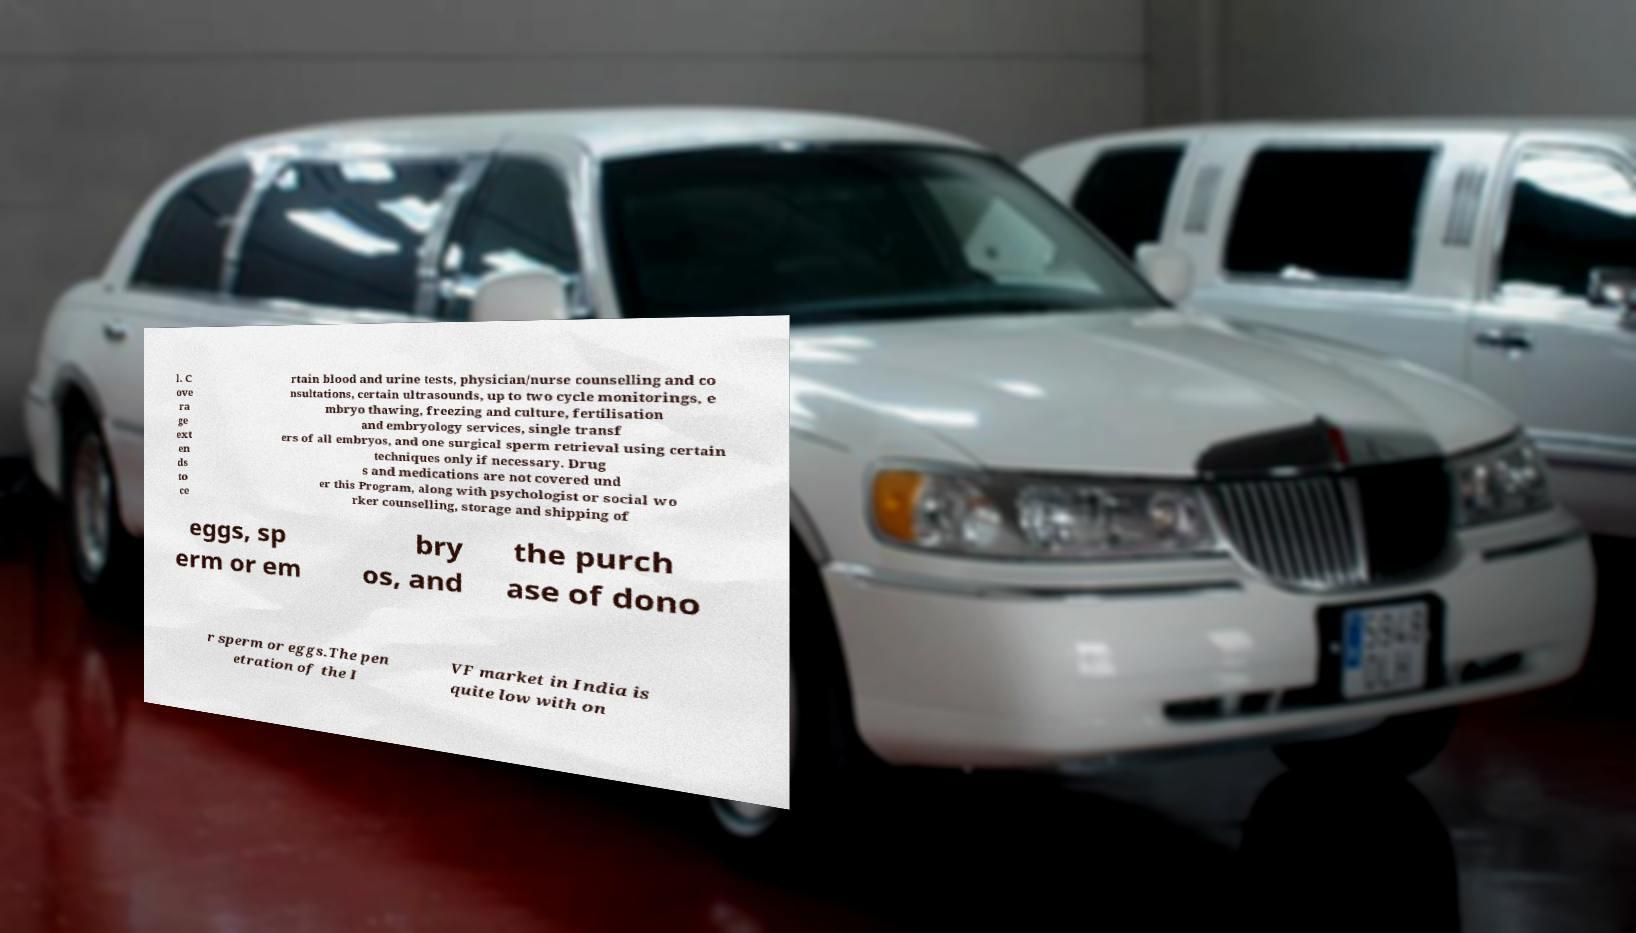Please read and relay the text visible in this image. What does it say? l. C ove ra ge ext en ds to ce rtain blood and urine tests, physician/nurse counselling and co nsultations, certain ultrasounds, up to two cycle monitorings, e mbryo thawing, freezing and culture, fertilisation and embryology services, single transf ers of all embryos, and one surgical sperm retrieval using certain techniques only if necessary. Drug s and medications are not covered und er this Program, along with psychologist or social wo rker counselling, storage and shipping of eggs, sp erm or em bry os, and the purch ase of dono r sperm or eggs.The pen etration of the I VF market in India is quite low with on 